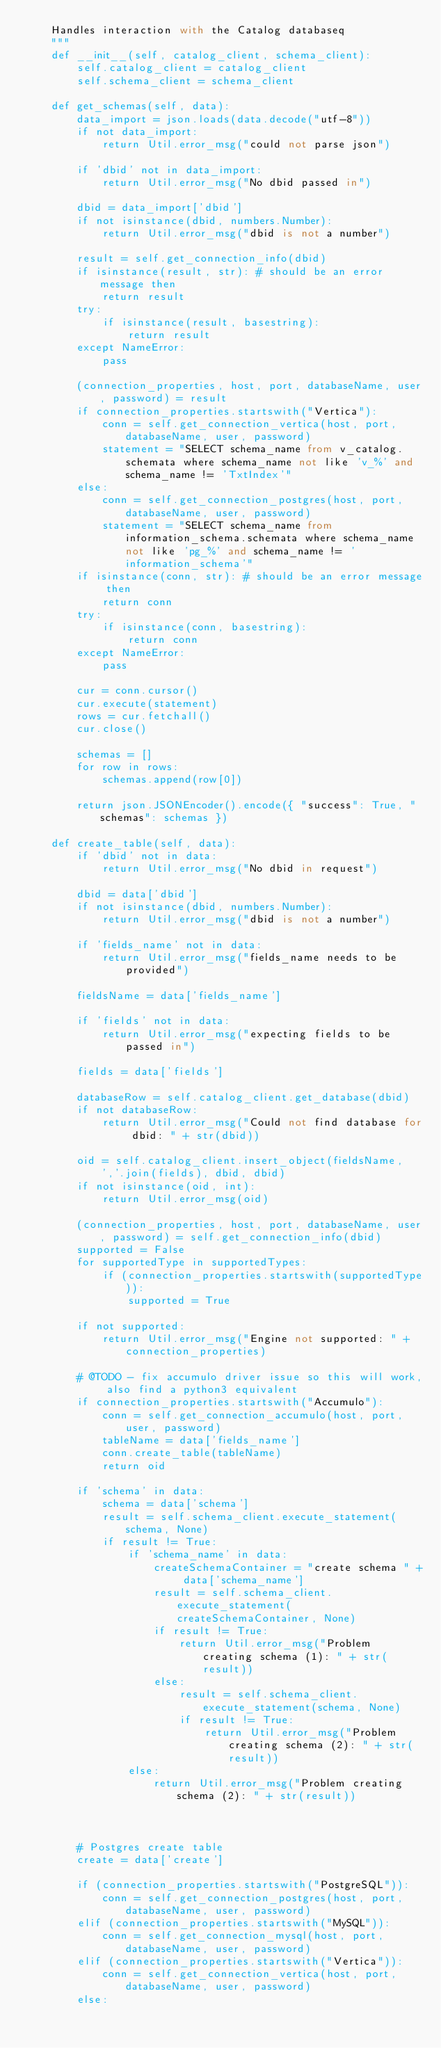Convert code to text. <code><loc_0><loc_0><loc_500><loc_500><_Python_>    Handles interaction with the Catalog databaseq
    """
    def __init__(self, catalog_client, schema_client):
        self.catalog_client = catalog_client
        self.schema_client = schema_client

    def get_schemas(self, data):
        data_import = json.loads(data.decode("utf-8"))
        if not data_import:
            return Util.error_msg("could not parse json")

        if 'dbid' not in data_import:
            return Util.error_msg("No dbid passed in")

        dbid = data_import['dbid']
        if not isinstance(dbid, numbers.Number):
            return Util.error_msg("dbid is not a number")

        result = self.get_connection_info(dbid)
        if isinstance(result, str): # should be an error message then
            return result
        try:
            if isinstance(result, basestring):
                return result
        except NameError:
            pass

        (connection_properties, host, port, databaseName, user, password) = result
        if connection_properties.startswith("Vertica"):
            conn = self.get_connection_vertica(host, port, databaseName, user, password)
            statement = "SELECT schema_name from v_catalog.schemata where schema_name not like 'v_%' and schema_name != 'TxtIndex'"
        else:
            conn = self.get_connection_postgres(host, port, databaseName, user, password)
            statement = "SELECT schema_name from information_schema.schemata where schema_name not like 'pg_%' and schema_name != 'information_schema'"
        if isinstance(conn, str): # should be an error message then
            return conn
        try:
            if isinstance(conn, basestring):
                return conn
        except NameError:
            pass

        cur = conn.cursor()
        cur.execute(statement)
        rows = cur.fetchall()
        cur.close()

        schemas = []
        for row in rows:
            schemas.append(row[0])

        return json.JSONEncoder().encode({ "success": True, "schemas": schemas })

    def create_table(self, data):
        if 'dbid' not in data:
            return Util.error_msg("No dbid in request")

        dbid = data['dbid']
        if not isinstance(dbid, numbers.Number):
            return Util.error_msg("dbid is not a number")

        if 'fields_name' not in data:
            return Util.error_msg("fields_name needs to be provided")

        fieldsName = data['fields_name']

        if 'fields' not in data:
            return Util.error_msg("expecting fields to be passed in")

        fields = data['fields']

        databaseRow = self.catalog_client.get_database(dbid)
        if not databaseRow:
            return Util.error_msg("Could not find database for dbid: " + str(dbid))

        oid = self.catalog_client.insert_object(fieldsName, ','.join(fields), dbid, dbid)
        if not isinstance(oid, int):
            return Util.error_msg(oid)

        (connection_properties, host, port, databaseName, user, password) = self.get_connection_info(dbid)
        supported = False
        for supportedType in supportedTypes:
            if (connection_properties.startswith(supportedType)):
                supported = True

        if not supported:
            return Util.error_msg("Engine not supported: " + connection_properties)

        # @TODO - fix accumulo driver issue so this will work, also find a python3 equivalent
        if connection_properties.startswith("Accumulo"):
            conn = self.get_connection_accumulo(host, port, user, password)
            tableName = data['fields_name']
            conn.create_table(tableName)
            return oid

        if 'schema' in data:
            schema = data['schema']
            result = self.schema_client.execute_statement(schema, None)
            if result != True:
                if 'schema_name' in data:
                    createSchemaContainer = "create schema " + data['schema_name']
                    result = self.schema_client.execute_statement(createSchemaContainer, None)
                    if result != True:
                        return Util.error_msg("Problem creating schema (1): " + str(result))
                    else:
                        result = self.schema_client.execute_statement(schema, None)
                        if result != True:
                            return Util.error_msg("Problem creating schema (2): " + str(result))
                else:
                    return Util.error_msg("Problem creating schema (2): " + str(result))



        # Postgres create table
        create = data['create']

        if (connection_properties.startswith("PostgreSQL")):
            conn = self.get_connection_postgres(host, port, databaseName, user, password)
        elif (connection_properties.startswith("MySQL")):
            conn = self.get_connection_mysql(host, port, databaseName, user, password)
        elif (connection_properties.startswith("Vertica")):
            conn = self.get_connection_vertica(host, port, databaseName, user, password)
        else:</code> 